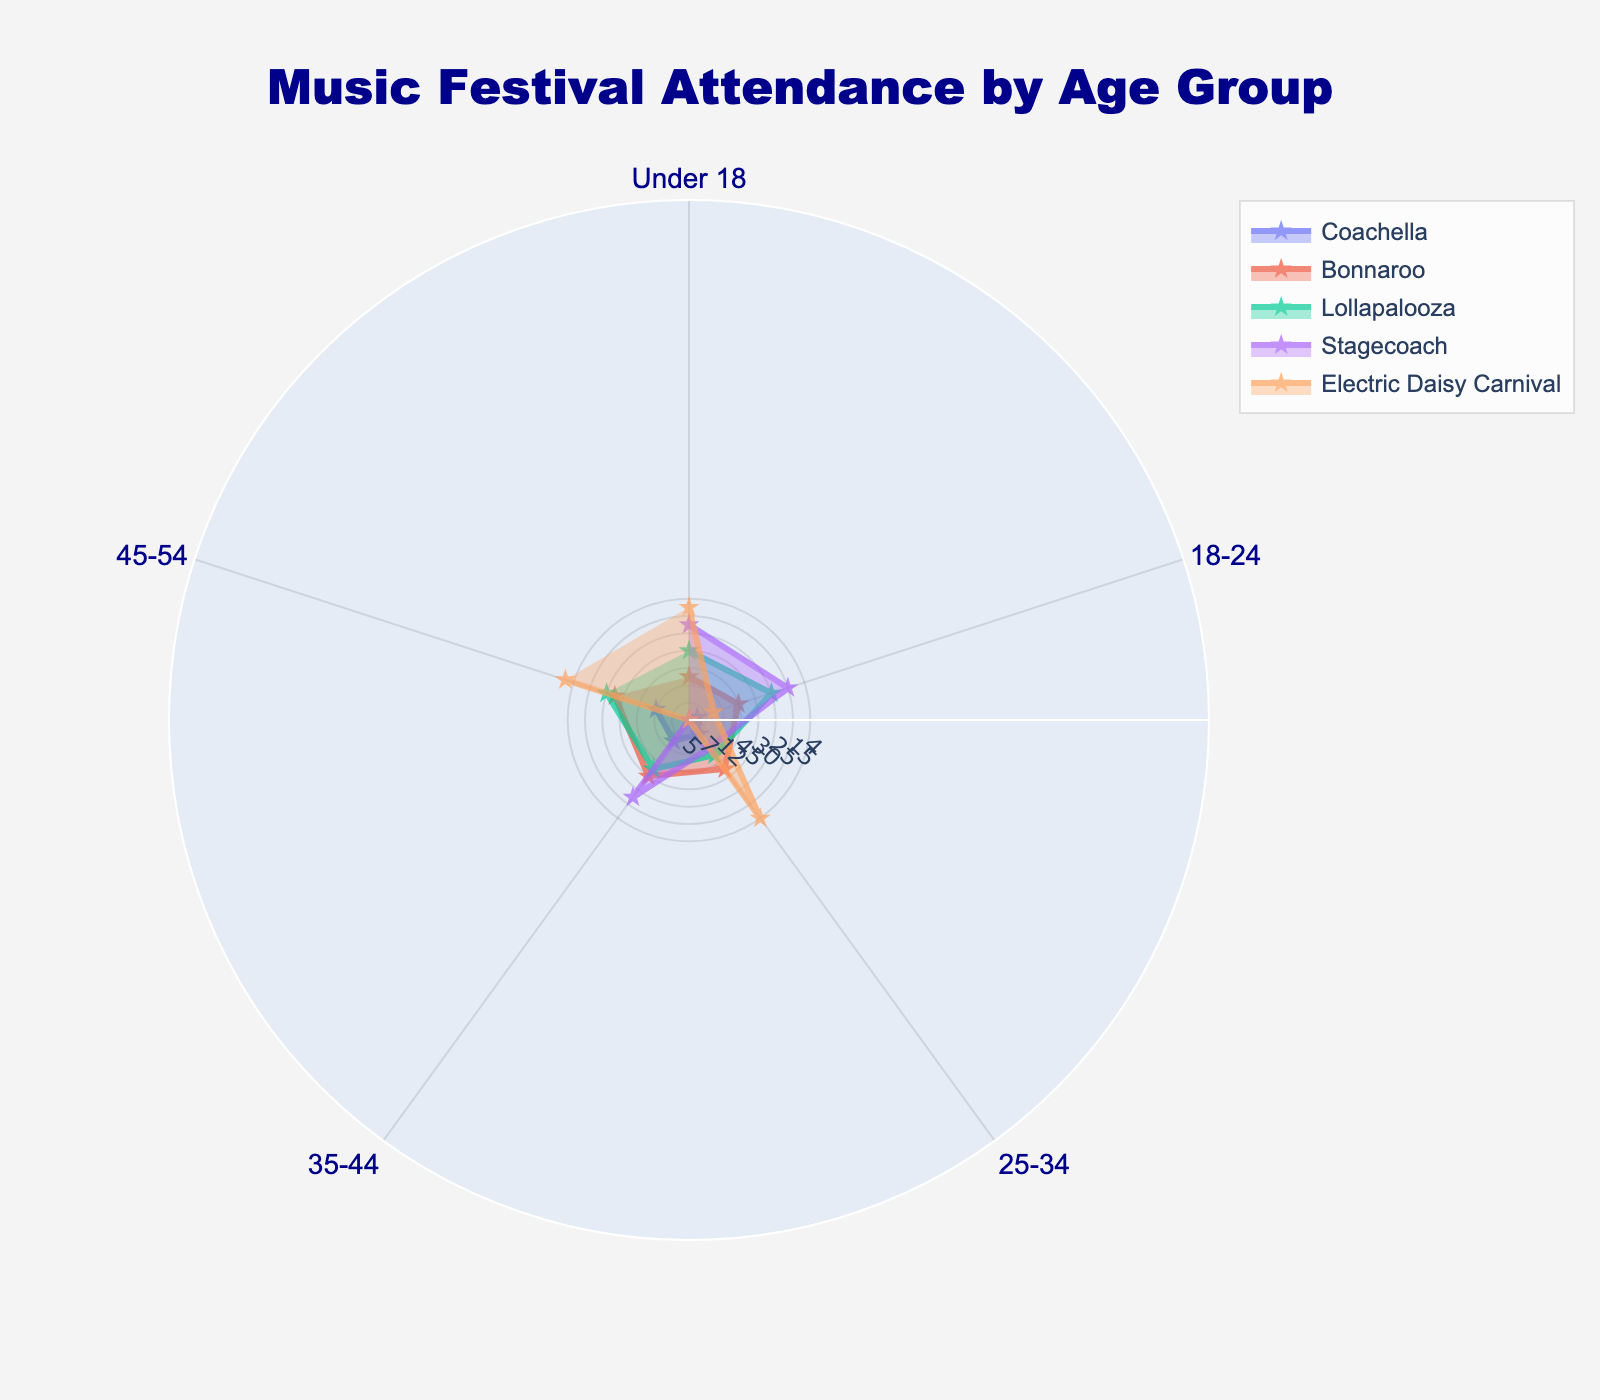What is the title of the polar chart? The title of the chart is displayed prominently at the top of the image. It indicates the subject of the chart: "Music Festival Attendance by Age Group".
Answer: Music Festival Attendance by Age Group Which age group has the highest attendance rate at Electric Daisy Carnival? Look for the data point on the chart corresponding to Electric Daisy Carnival that is farthest from the center within the circle labeled for age groups. The highest attendance rate is in the 18-24 age group.
Answer: 18-24 What is the attendance rate for the age group 25-34 at Stagecoach? Identify the data point for Stagecoach within the section labeled 25-34. The value shown represents the attendance rate.
Answer: 40 How does the attendance rate for under 18 at Bonnaroo compare to Coachella? Examine the values in the under 18 category for both Bonnaroo and Coachella. Compare the two values; Bonnaroo has an attendance rate of 10 and Coachella has 5.
Answer: Bonnaroo has a higher rate Calculate the average attendance rate for the age group 35-44 across all festivals. Sum the attendance rates for 35-44 across all the festivals: (20 + 15 + 12 + 20 + 5), then divide by the number of festivals (5). Calculation: (20 + 15 + 12 + 20 + 5) / 5 = 72 / 5 = 14.4
Answer: 14.4 Which festival has the most balanced attendance across all age groups? Look at the shapes of the plots to see which one covers the most uniform area throughout the age groups. Coachella and Lollapalooza appear to have a relatively balanced distribution across all age groups.
Answer: Coachella and Lollapalooza What is the largest difference in attendance rate between any two age groups at Lollapalooza? Identify the highest and lowest attendance rate values for Lollapalooza on the chart (40 for 18-24 and 2 for 55 and above), then calculate their difference: 40 - 2 = 38.
Answer: 38 What proportion of attendees at Bonnaroo are aged 18-24? Identify the attendance rate for the age group 18-24 at Bonnaroo (45), and compare it with the total range limit (60 indicated on the chart). The proportion is calculated as 45/60 = 0.75.
Answer: 75% Which two age groups at Coachella have the closest attendance rates? Compare all pairs of age group attendance rates for Coachella. The values are: Under 18 (5), 18-24 (35), 25-34 (30), 35-44 (20), 45-54 (8), 55 and above (2). The closest are 25-34 (30) and 35-44 (20).
Answer: 25-34 and 35-44 